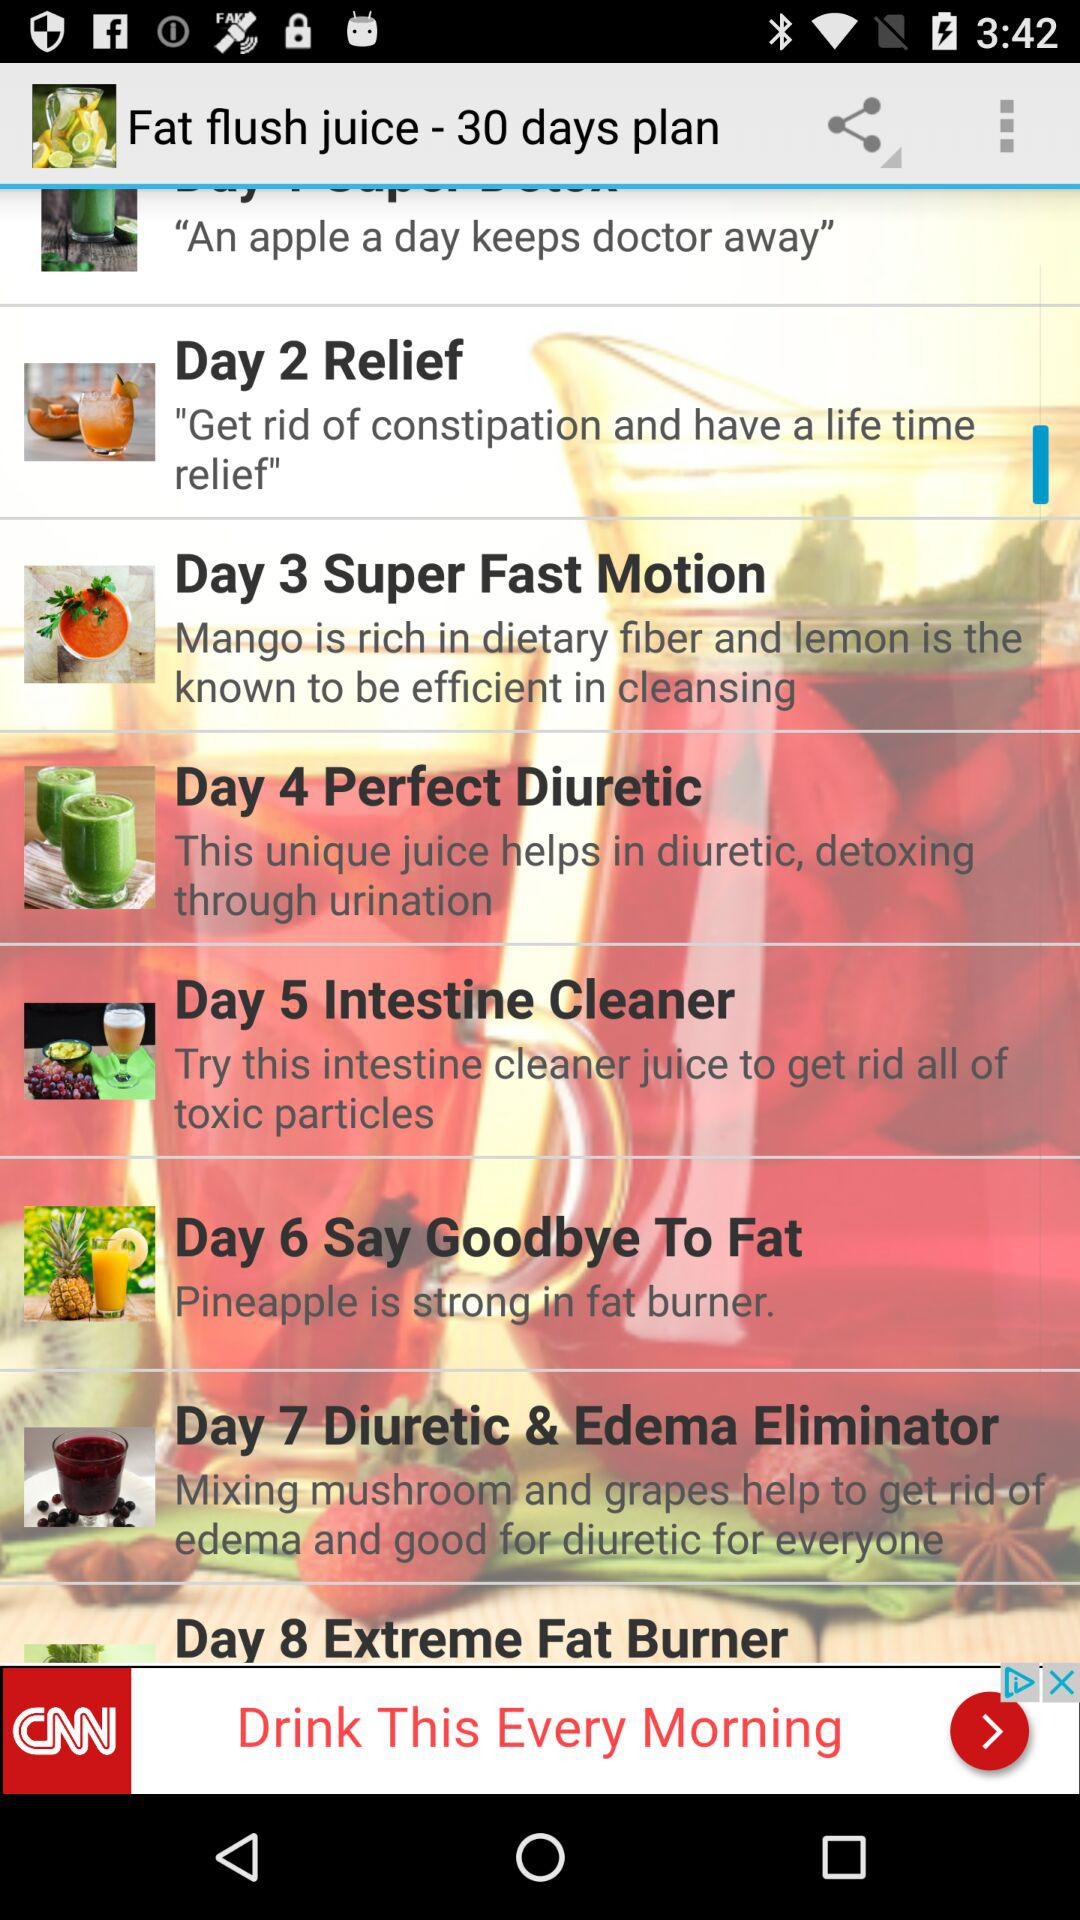How many days are in the plan? There are 30 days in the plan. 